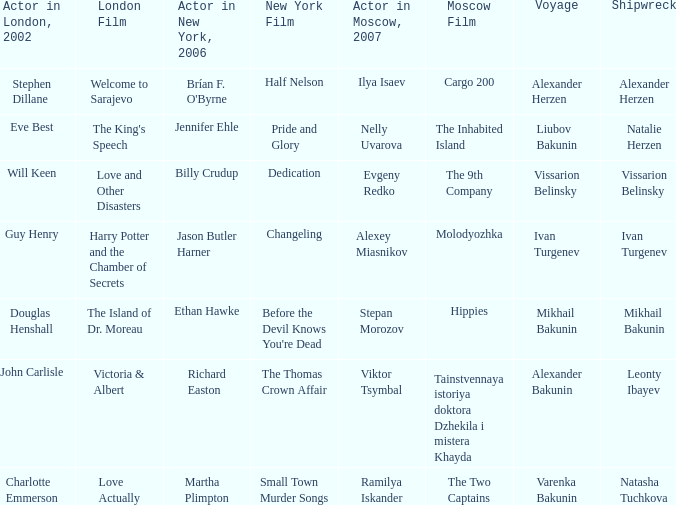Who was the 2007 actor from Moscow for the shipwreck of Leonty Ibayev? Viktor Tsymbal. 